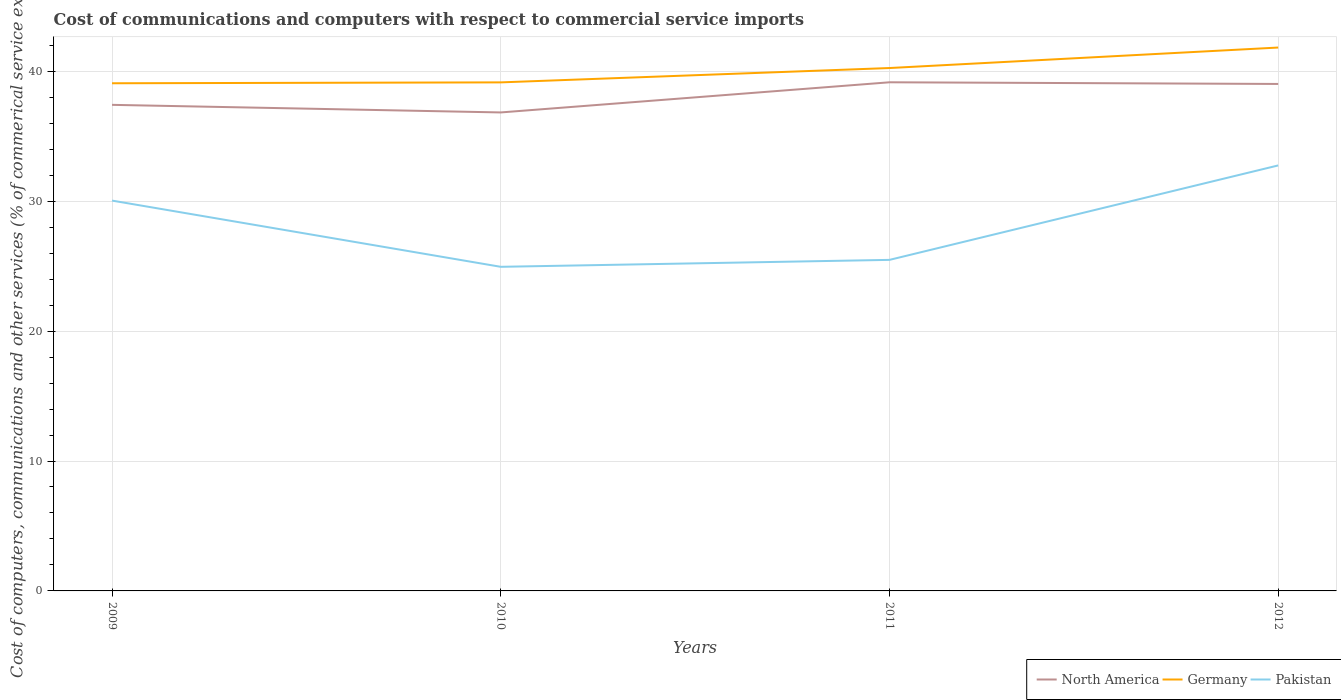Across all years, what is the maximum cost of communications and computers in North America?
Offer a terse response. 36.83. In which year was the cost of communications and computers in Pakistan maximum?
Make the answer very short. 2010. What is the total cost of communications and computers in Germany in the graph?
Provide a short and direct response. -1.1. What is the difference between the highest and the second highest cost of communications and computers in North America?
Offer a terse response. 2.32. What is the difference between the highest and the lowest cost of communications and computers in Pakistan?
Keep it short and to the point. 2. How many years are there in the graph?
Give a very brief answer. 4. What is the difference between two consecutive major ticks on the Y-axis?
Provide a succinct answer. 10. Are the values on the major ticks of Y-axis written in scientific E-notation?
Offer a terse response. No. Does the graph contain any zero values?
Your answer should be compact. No. Where does the legend appear in the graph?
Ensure brevity in your answer.  Bottom right. How are the legend labels stacked?
Your response must be concise. Horizontal. What is the title of the graph?
Your answer should be very brief. Cost of communications and computers with respect to commercial service imports. Does "El Salvador" appear as one of the legend labels in the graph?
Provide a short and direct response. No. What is the label or title of the Y-axis?
Keep it short and to the point. Cost of computers, communications and other services (% of commerical service exports). What is the Cost of computers, communications and other services (% of commerical service exports) of North America in 2009?
Offer a very short reply. 37.41. What is the Cost of computers, communications and other services (% of commerical service exports) of Germany in 2009?
Your answer should be compact. 39.07. What is the Cost of computers, communications and other services (% of commerical service exports) in Pakistan in 2009?
Your response must be concise. 30.04. What is the Cost of computers, communications and other services (% of commerical service exports) of North America in 2010?
Offer a terse response. 36.83. What is the Cost of computers, communications and other services (% of commerical service exports) of Germany in 2010?
Your answer should be very brief. 39.14. What is the Cost of computers, communications and other services (% of commerical service exports) in Pakistan in 2010?
Your answer should be compact. 24.95. What is the Cost of computers, communications and other services (% of commerical service exports) of North America in 2011?
Keep it short and to the point. 39.15. What is the Cost of computers, communications and other services (% of commerical service exports) of Germany in 2011?
Offer a very short reply. 40.25. What is the Cost of computers, communications and other services (% of commerical service exports) of Pakistan in 2011?
Provide a short and direct response. 25.48. What is the Cost of computers, communications and other services (% of commerical service exports) in North America in 2012?
Ensure brevity in your answer.  39.02. What is the Cost of computers, communications and other services (% of commerical service exports) in Germany in 2012?
Your answer should be compact. 41.82. What is the Cost of computers, communications and other services (% of commerical service exports) of Pakistan in 2012?
Give a very brief answer. 32.75. Across all years, what is the maximum Cost of computers, communications and other services (% of commerical service exports) in North America?
Give a very brief answer. 39.15. Across all years, what is the maximum Cost of computers, communications and other services (% of commerical service exports) of Germany?
Provide a short and direct response. 41.82. Across all years, what is the maximum Cost of computers, communications and other services (% of commerical service exports) in Pakistan?
Make the answer very short. 32.75. Across all years, what is the minimum Cost of computers, communications and other services (% of commerical service exports) in North America?
Your answer should be very brief. 36.83. Across all years, what is the minimum Cost of computers, communications and other services (% of commerical service exports) in Germany?
Ensure brevity in your answer.  39.07. Across all years, what is the minimum Cost of computers, communications and other services (% of commerical service exports) of Pakistan?
Your answer should be compact. 24.95. What is the total Cost of computers, communications and other services (% of commerical service exports) in North America in the graph?
Your answer should be compact. 152.41. What is the total Cost of computers, communications and other services (% of commerical service exports) in Germany in the graph?
Provide a short and direct response. 160.29. What is the total Cost of computers, communications and other services (% of commerical service exports) in Pakistan in the graph?
Your answer should be very brief. 113.22. What is the difference between the Cost of computers, communications and other services (% of commerical service exports) in North America in 2009 and that in 2010?
Ensure brevity in your answer.  0.58. What is the difference between the Cost of computers, communications and other services (% of commerical service exports) in Germany in 2009 and that in 2010?
Your response must be concise. -0.07. What is the difference between the Cost of computers, communications and other services (% of commerical service exports) of Pakistan in 2009 and that in 2010?
Provide a succinct answer. 5.1. What is the difference between the Cost of computers, communications and other services (% of commerical service exports) in North America in 2009 and that in 2011?
Ensure brevity in your answer.  -1.74. What is the difference between the Cost of computers, communications and other services (% of commerical service exports) of Germany in 2009 and that in 2011?
Provide a succinct answer. -1.17. What is the difference between the Cost of computers, communications and other services (% of commerical service exports) of Pakistan in 2009 and that in 2011?
Your response must be concise. 4.56. What is the difference between the Cost of computers, communications and other services (% of commerical service exports) of North America in 2009 and that in 2012?
Your response must be concise. -1.61. What is the difference between the Cost of computers, communications and other services (% of commerical service exports) in Germany in 2009 and that in 2012?
Offer a terse response. -2.75. What is the difference between the Cost of computers, communications and other services (% of commerical service exports) of Pakistan in 2009 and that in 2012?
Your answer should be very brief. -2.71. What is the difference between the Cost of computers, communications and other services (% of commerical service exports) of North America in 2010 and that in 2011?
Keep it short and to the point. -2.32. What is the difference between the Cost of computers, communications and other services (% of commerical service exports) of Germany in 2010 and that in 2011?
Your answer should be very brief. -1.1. What is the difference between the Cost of computers, communications and other services (% of commerical service exports) of Pakistan in 2010 and that in 2011?
Make the answer very short. -0.53. What is the difference between the Cost of computers, communications and other services (% of commerical service exports) of North America in 2010 and that in 2012?
Provide a short and direct response. -2.19. What is the difference between the Cost of computers, communications and other services (% of commerical service exports) of Germany in 2010 and that in 2012?
Your answer should be very brief. -2.68. What is the difference between the Cost of computers, communications and other services (% of commerical service exports) in Pakistan in 2010 and that in 2012?
Offer a very short reply. -7.8. What is the difference between the Cost of computers, communications and other services (% of commerical service exports) in North America in 2011 and that in 2012?
Give a very brief answer. 0.13. What is the difference between the Cost of computers, communications and other services (% of commerical service exports) of Germany in 2011 and that in 2012?
Your response must be concise. -1.58. What is the difference between the Cost of computers, communications and other services (% of commerical service exports) of Pakistan in 2011 and that in 2012?
Your answer should be very brief. -7.27. What is the difference between the Cost of computers, communications and other services (% of commerical service exports) of North America in 2009 and the Cost of computers, communications and other services (% of commerical service exports) of Germany in 2010?
Provide a short and direct response. -1.73. What is the difference between the Cost of computers, communications and other services (% of commerical service exports) of North America in 2009 and the Cost of computers, communications and other services (% of commerical service exports) of Pakistan in 2010?
Your answer should be compact. 12.47. What is the difference between the Cost of computers, communications and other services (% of commerical service exports) in Germany in 2009 and the Cost of computers, communications and other services (% of commerical service exports) in Pakistan in 2010?
Give a very brief answer. 14.13. What is the difference between the Cost of computers, communications and other services (% of commerical service exports) of North America in 2009 and the Cost of computers, communications and other services (% of commerical service exports) of Germany in 2011?
Give a very brief answer. -2.83. What is the difference between the Cost of computers, communications and other services (% of commerical service exports) in North America in 2009 and the Cost of computers, communications and other services (% of commerical service exports) in Pakistan in 2011?
Your answer should be compact. 11.93. What is the difference between the Cost of computers, communications and other services (% of commerical service exports) of Germany in 2009 and the Cost of computers, communications and other services (% of commerical service exports) of Pakistan in 2011?
Give a very brief answer. 13.59. What is the difference between the Cost of computers, communications and other services (% of commerical service exports) of North America in 2009 and the Cost of computers, communications and other services (% of commerical service exports) of Germany in 2012?
Your response must be concise. -4.41. What is the difference between the Cost of computers, communications and other services (% of commerical service exports) in North America in 2009 and the Cost of computers, communications and other services (% of commerical service exports) in Pakistan in 2012?
Keep it short and to the point. 4.66. What is the difference between the Cost of computers, communications and other services (% of commerical service exports) in Germany in 2009 and the Cost of computers, communications and other services (% of commerical service exports) in Pakistan in 2012?
Ensure brevity in your answer.  6.32. What is the difference between the Cost of computers, communications and other services (% of commerical service exports) in North America in 2010 and the Cost of computers, communications and other services (% of commerical service exports) in Germany in 2011?
Provide a succinct answer. -3.42. What is the difference between the Cost of computers, communications and other services (% of commerical service exports) in North America in 2010 and the Cost of computers, communications and other services (% of commerical service exports) in Pakistan in 2011?
Your answer should be compact. 11.35. What is the difference between the Cost of computers, communications and other services (% of commerical service exports) in Germany in 2010 and the Cost of computers, communications and other services (% of commerical service exports) in Pakistan in 2011?
Make the answer very short. 13.66. What is the difference between the Cost of computers, communications and other services (% of commerical service exports) in North America in 2010 and the Cost of computers, communications and other services (% of commerical service exports) in Germany in 2012?
Keep it short and to the point. -5. What is the difference between the Cost of computers, communications and other services (% of commerical service exports) in North America in 2010 and the Cost of computers, communications and other services (% of commerical service exports) in Pakistan in 2012?
Keep it short and to the point. 4.08. What is the difference between the Cost of computers, communications and other services (% of commerical service exports) of Germany in 2010 and the Cost of computers, communications and other services (% of commerical service exports) of Pakistan in 2012?
Ensure brevity in your answer.  6.39. What is the difference between the Cost of computers, communications and other services (% of commerical service exports) in North America in 2011 and the Cost of computers, communications and other services (% of commerical service exports) in Germany in 2012?
Keep it short and to the point. -2.67. What is the difference between the Cost of computers, communications and other services (% of commerical service exports) of North America in 2011 and the Cost of computers, communications and other services (% of commerical service exports) of Pakistan in 2012?
Your answer should be very brief. 6.4. What is the difference between the Cost of computers, communications and other services (% of commerical service exports) of Germany in 2011 and the Cost of computers, communications and other services (% of commerical service exports) of Pakistan in 2012?
Ensure brevity in your answer.  7.5. What is the average Cost of computers, communications and other services (% of commerical service exports) of North America per year?
Your answer should be very brief. 38.1. What is the average Cost of computers, communications and other services (% of commerical service exports) in Germany per year?
Your response must be concise. 40.07. What is the average Cost of computers, communications and other services (% of commerical service exports) of Pakistan per year?
Give a very brief answer. 28.31. In the year 2009, what is the difference between the Cost of computers, communications and other services (% of commerical service exports) in North America and Cost of computers, communications and other services (% of commerical service exports) in Germany?
Your answer should be compact. -1.66. In the year 2009, what is the difference between the Cost of computers, communications and other services (% of commerical service exports) in North America and Cost of computers, communications and other services (% of commerical service exports) in Pakistan?
Offer a very short reply. 7.37. In the year 2009, what is the difference between the Cost of computers, communications and other services (% of commerical service exports) of Germany and Cost of computers, communications and other services (% of commerical service exports) of Pakistan?
Make the answer very short. 9.03. In the year 2010, what is the difference between the Cost of computers, communications and other services (% of commerical service exports) in North America and Cost of computers, communications and other services (% of commerical service exports) in Germany?
Your answer should be compact. -2.31. In the year 2010, what is the difference between the Cost of computers, communications and other services (% of commerical service exports) in North America and Cost of computers, communications and other services (% of commerical service exports) in Pakistan?
Your answer should be very brief. 11.88. In the year 2010, what is the difference between the Cost of computers, communications and other services (% of commerical service exports) of Germany and Cost of computers, communications and other services (% of commerical service exports) of Pakistan?
Make the answer very short. 14.2. In the year 2011, what is the difference between the Cost of computers, communications and other services (% of commerical service exports) of North America and Cost of computers, communications and other services (% of commerical service exports) of Germany?
Offer a terse response. -1.1. In the year 2011, what is the difference between the Cost of computers, communications and other services (% of commerical service exports) in North America and Cost of computers, communications and other services (% of commerical service exports) in Pakistan?
Offer a very short reply. 13.67. In the year 2011, what is the difference between the Cost of computers, communications and other services (% of commerical service exports) of Germany and Cost of computers, communications and other services (% of commerical service exports) of Pakistan?
Give a very brief answer. 14.77. In the year 2012, what is the difference between the Cost of computers, communications and other services (% of commerical service exports) in North America and Cost of computers, communications and other services (% of commerical service exports) in Germany?
Give a very brief answer. -2.8. In the year 2012, what is the difference between the Cost of computers, communications and other services (% of commerical service exports) in North America and Cost of computers, communications and other services (% of commerical service exports) in Pakistan?
Provide a succinct answer. 6.27. In the year 2012, what is the difference between the Cost of computers, communications and other services (% of commerical service exports) in Germany and Cost of computers, communications and other services (% of commerical service exports) in Pakistan?
Give a very brief answer. 9.07. What is the ratio of the Cost of computers, communications and other services (% of commerical service exports) in North America in 2009 to that in 2010?
Offer a terse response. 1.02. What is the ratio of the Cost of computers, communications and other services (% of commerical service exports) in Germany in 2009 to that in 2010?
Your answer should be very brief. 1. What is the ratio of the Cost of computers, communications and other services (% of commerical service exports) of Pakistan in 2009 to that in 2010?
Ensure brevity in your answer.  1.2. What is the ratio of the Cost of computers, communications and other services (% of commerical service exports) in North America in 2009 to that in 2011?
Provide a short and direct response. 0.96. What is the ratio of the Cost of computers, communications and other services (% of commerical service exports) in Germany in 2009 to that in 2011?
Your answer should be compact. 0.97. What is the ratio of the Cost of computers, communications and other services (% of commerical service exports) of Pakistan in 2009 to that in 2011?
Keep it short and to the point. 1.18. What is the ratio of the Cost of computers, communications and other services (% of commerical service exports) in North America in 2009 to that in 2012?
Your answer should be compact. 0.96. What is the ratio of the Cost of computers, communications and other services (% of commerical service exports) of Germany in 2009 to that in 2012?
Provide a short and direct response. 0.93. What is the ratio of the Cost of computers, communications and other services (% of commerical service exports) in Pakistan in 2009 to that in 2012?
Your answer should be very brief. 0.92. What is the ratio of the Cost of computers, communications and other services (% of commerical service exports) of North America in 2010 to that in 2011?
Ensure brevity in your answer.  0.94. What is the ratio of the Cost of computers, communications and other services (% of commerical service exports) in Germany in 2010 to that in 2011?
Offer a very short reply. 0.97. What is the ratio of the Cost of computers, communications and other services (% of commerical service exports) of North America in 2010 to that in 2012?
Your answer should be very brief. 0.94. What is the ratio of the Cost of computers, communications and other services (% of commerical service exports) of Germany in 2010 to that in 2012?
Your response must be concise. 0.94. What is the ratio of the Cost of computers, communications and other services (% of commerical service exports) in Pakistan in 2010 to that in 2012?
Give a very brief answer. 0.76. What is the ratio of the Cost of computers, communications and other services (% of commerical service exports) in North America in 2011 to that in 2012?
Ensure brevity in your answer.  1. What is the ratio of the Cost of computers, communications and other services (% of commerical service exports) in Germany in 2011 to that in 2012?
Offer a very short reply. 0.96. What is the ratio of the Cost of computers, communications and other services (% of commerical service exports) in Pakistan in 2011 to that in 2012?
Your answer should be compact. 0.78. What is the difference between the highest and the second highest Cost of computers, communications and other services (% of commerical service exports) of North America?
Offer a very short reply. 0.13. What is the difference between the highest and the second highest Cost of computers, communications and other services (% of commerical service exports) in Germany?
Your response must be concise. 1.58. What is the difference between the highest and the second highest Cost of computers, communications and other services (% of commerical service exports) in Pakistan?
Give a very brief answer. 2.71. What is the difference between the highest and the lowest Cost of computers, communications and other services (% of commerical service exports) in North America?
Ensure brevity in your answer.  2.32. What is the difference between the highest and the lowest Cost of computers, communications and other services (% of commerical service exports) of Germany?
Provide a succinct answer. 2.75. What is the difference between the highest and the lowest Cost of computers, communications and other services (% of commerical service exports) in Pakistan?
Offer a terse response. 7.8. 